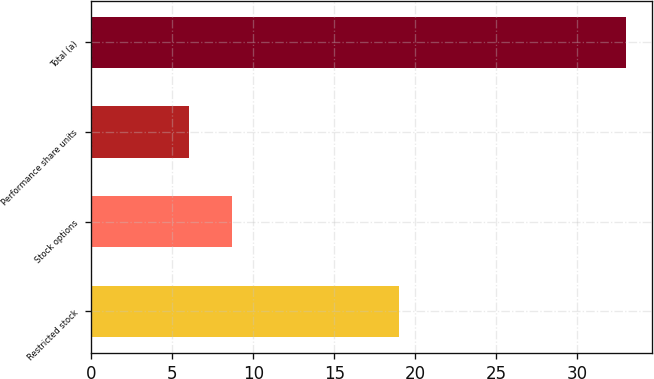<chart> <loc_0><loc_0><loc_500><loc_500><bar_chart><fcel>Restricted stock<fcel>Stock options<fcel>Performance share units<fcel>Total (a)<nl><fcel>19<fcel>8.7<fcel>6<fcel>33<nl></chart> 